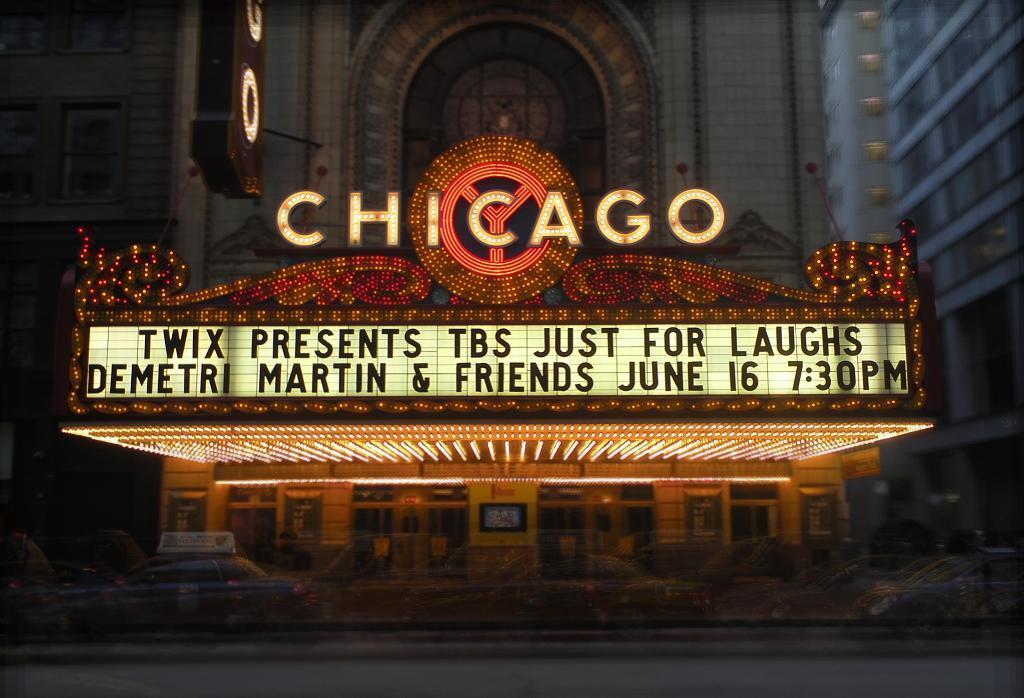Could you give a brief overview of what you see in this image? In this picture I can see buildings and I can see text and I can see cars moving on the road. 